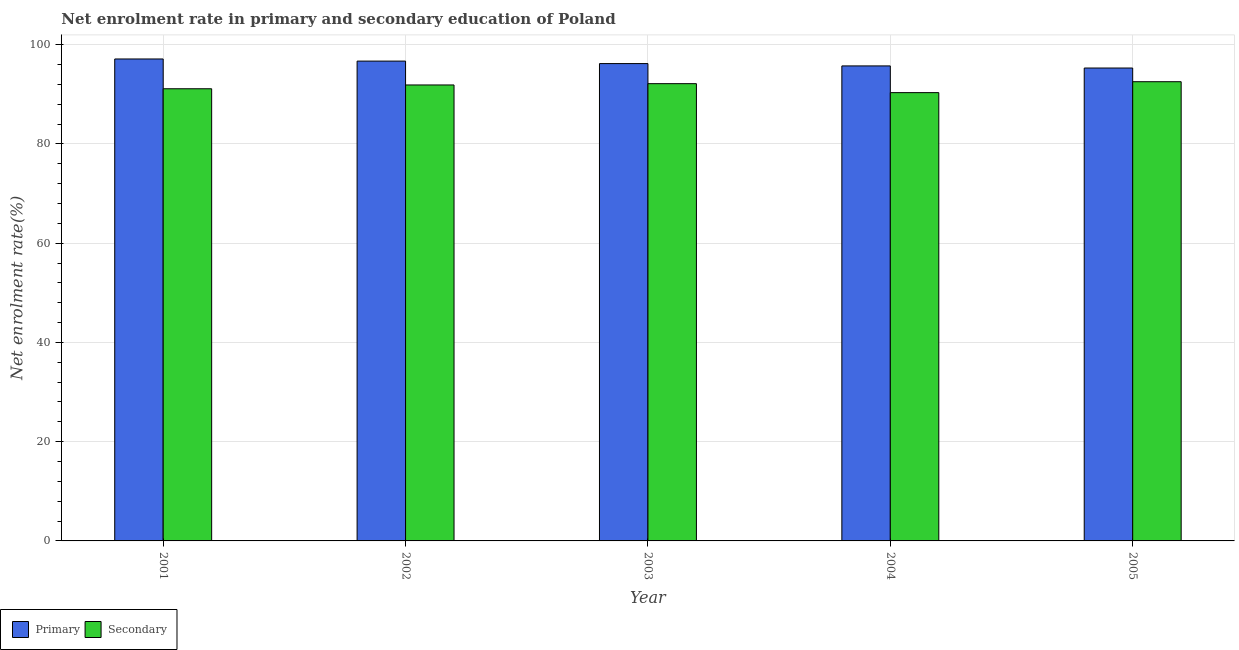How many different coloured bars are there?
Give a very brief answer. 2. How many groups of bars are there?
Offer a terse response. 5. Are the number of bars per tick equal to the number of legend labels?
Your response must be concise. Yes. Are the number of bars on each tick of the X-axis equal?
Your answer should be very brief. Yes. In how many cases, is the number of bars for a given year not equal to the number of legend labels?
Your answer should be very brief. 0. What is the enrollment rate in secondary education in 2002?
Offer a very short reply. 91.88. Across all years, what is the maximum enrollment rate in secondary education?
Your answer should be compact. 92.53. Across all years, what is the minimum enrollment rate in secondary education?
Your response must be concise. 90.33. In which year was the enrollment rate in primary education maximum?
Offer a terse response. 2001. What is the total enrollment rate in primary education in the graph?
Provide a short and direct response. 480.98. What is the difference between the enrollment rate in secondary education in 2002 and that in 2005?
Keep it short and to the point. -0.66. What is the difference between the enrollment rate in secondary education in 2005 and the enrollment rate in primary education in 2004?
Ensure brevity in your answer.  2.2. What is the average enrollment rate in primary education per year?
Ensure brevity in your answer.  96.2. In the year 2004, what is the difference between the enrollment rate in primary education and enrollment rate in secondary education?
Give a very brief answer. 0. In how many years, is the enrollment rate in primary education greater than 88 %?
Offer a very short reply. 5. What is the ratio of the enrollment rate in primary education in 2002 to that in 2003?
Your answer should be compact. 1.01. Is the difference between the enrollment rate in secondary education in 2002 and 2004 greater than the difference between the enrollment rate in primary education in 2002 and 2004?
Give a very brief answer. No. What is the difference between the highest and the second highest enrollment rate in primary education?
Provide a succinct answer. 0.43. What is the difference between the highest and the lowest enrollment rate in secondary education?
Keep it short and to the point. 2.2. What does the 2nd bar from the left in 2003 represents?
Keep it short and to the point. Secondary. What does the 2nd bar from the right in 2005 represents?
Give a very brief answer. Primary. Are all the bars in the graph horizontal?
Keep it short and to the point. No. How many years are there in the graph?
Offer a very short reply. 5. Are the values on the major ticks of Y-axis written in scientific E-notation?
Your answer should be compact. No. Where does the legend appear in the graph?
Provide a succinct answer. Bottom left. How many legend labels are there?
Your response must be concise. 2. What is the title of the graph?
Your answer should be very brief. Net enrolment rate in primary and secondary education of Poland. Does "Merchandise exports" appear as one of the legend labels in the graph?
Offer a very short reply. No. What is the label or title of the X-axis?
Make the answer very short. Year. What is the label or title of the Y-axis?
Offer a very short reply. Net enrolment rate(%). What is the Net enrolment rate(%) of Primary in 2001?
Provide a succinct answer. 97.11. What is the Net enrolment rate(%) of Secondary in 2001?
Your response must be concise. 91.11. What is the Net enrolment rate(%) of Primary in 2002?
Give a very brief answer. 96.68. What is the Net enrolment rate(%) of Secondary in 2002?
Provide a short and direct response. 91.88. What is the Net enrolment rate(%) in Primary in 2003?
Your answer should be very brief. 96.18. What is the Net enrolment rate(%) of Secondary in 2003?
Your response must be concise. 92.14. What is the Net enrolment rate(%) of Primary in 2004?
Ensure brevity in your answer.  95.71. What is the Net enrolment rate(%) in Secondary in 2004?
Make the answer very short. 90.33. What is the Net enrolment rate(%) in Primary in 2005?
Provide a short and direct response. 95.29. What is the Net enrolment rate(%) in Secondary in 2005?
Ensure brevity in your answer.  92.53. Across all years, what is the maximum Net enrolment rate(%) of Primary?
Offer a terse response. 97.11. Across all years, what is the maximum Net enrolment rate(%) in Secondary?
Offer a terse response. 92.53. Across all years, what is the minimum Net enrolment rate(%) of Primary?
Ensure brevity in your answer.  95.29. Across all years, what is the minimum Net enrolment rate(%) of Secondary?
Offer a terse response. 90.33. What is the total Net enrolment rate(%) in Primary in the graph?
Provide a succinct answer. 480.98. What is the total Net enrolment rate(%) of Secondary in the graph?
Offer a terse response. 457.99. What is the difference between the Net enrolment rate(%) of Primary in 2001 and that in 2002?
Your response must be concise. 0.43. What is the difference between the Net enrolment rate(%) of Secondary in 2001 and that in 2002?
Offer a terse response. -0.77. What is the difference between the Net enrolment rate(%) of Primary in 2001 and that in 2003?
Ensure brevity in your answer.  0.93. What is the difference between the Net enrolment rate(%) in Secondary in 2001 and that in 2003?
Make the answer very short. -1.03. What is the difference between the Net enrolment rate(%) of Primary in 2001 and that in 2004?
Make the answer very short. 1.4. What is the difference between the Net enrolment rate(%) of Secondary in 2001 and that in 2004?
Provide a short and direct response. 0.78. What is the difference between the Net enrolment rate(%) in Primary in 2001 and that in 2005?
Keep it short and to the point. 1.82. What is the difference between the Net enrolment rate(%) of Secondary in 2001 and that in 2005?
Offer a very short reply. -1.42. What is the difference between the Net enrolment rate(%) in Primary in 2002 and that in 2003?
Offer a terse response. 0.5. What is the difference between the Net enrolment rate(%) of Secondary in 2002 and that in 2003?
Make the answer very short. -0.26. What is the difference between the Net enrolment rate(%) in Primary in 2002 and that in 2004?
Offer a very short reply. 0.97. What is the difference between the Net enrolment rate(%) in Secondary in 2002 and that in 2004?
Your answer should be compact. 1.54. What is the difference between the Net enrolment rate(%) in Primary in 2002 and that in 2005?
Keep it short and to the point. 1.39. What is the difference between the Net enrolment rate(%) in Secondary in 2002 and that in 2005?
Provide a short and direct response. -0.66. What is the difference between the Net enrolment rate(%) of Primary in 2003 and that in 2004?
Ensure brevity in your answer.  0.47. What is the difference between the Net enrolment rate(%) of Secondary in 2003 and that in 2004?
Offer a very short reply. 1.81. What is the difference between the Net enrolment rate(%) in Primary in 2003 and that in 2005?
Keep it short and to the point. 0.89. What is the difference between the Net enrolment rate(%) of Secondary in 2003 and that in 2005?
Keep it short and to the point. -0.39. What is the difference between the Net enrolment rate(%) in Primary in 2004 and that in 2005?
Make the answer very short. 0.42. What is the difference between the Net enrolment rate(%) of Secondary in 2004 and that in 2005?
Give a very brief answer. -2.2. What is the difference between the Net enrolment rate(%) in Primary in 2001 and the Net enrolment rate(%) in Secondary in 2002?
Offer a terse response. 5.24. What is the difference between the Net enrolment rate(%) in Primary in 2001 and the Net enrolment rate(%) in Secondary in 2003?
Your answer should be compact. 4.97. What is the difference between the Net enrolment rate(%) of Primary in 2001 and the Net enrolment rate(%) of Secondary in 2004?
Make the answer very short. 6.78. What is the difference between the Net enrolment rate(%) of Primary in 2001 and the Net enrolment rate(%) of Secondary in 2005?
Offer a terse response. 4.58. What is the difference between the Net enrolment rate(%) in Primary in 2002 and the Net enrolment rate(%) in Secondary in 2003?
Provide a succinct answer. 4.55. What is the difference between the Net enrolment rate(%) of Primary in 2002 and the Net enrolment rate(%) of Secondary in 2004?
Provide a short and direct response. 6.35. What is the difference between the Net enrolment rate(%) in Primary in 2002 and the Net enrolment rate(%) in Secondary in 2005?
Keep it short and to the point. 4.15. What is the difference between the Net enrolment rate(%) of Primary in 2003 and the Net enrolment rate(%) of Secondary in 2004?
Provide a succinct answer. 5.85. What is the difference between the Net enrolment rate(%) in Primary in 2003 and the Net enrolment rate(%) in Secondary in 2005?
Ensure brevity in your answer.  3.65. What is the difference between the Net enrolment rate(%) of Primary in 2004 and the Net enrolment rate(%) of Secondary in 2005?
Offer a terse response. 3.18. What is the average Net enrolment rate(%) in Primary per year?
Make the answer very short. 96.2. What is the average Net enrolment rate(%) in Secondary per year?
Your answer should be very brief. 91.6. In the year 2001, what is the difference between the Net enrolment rate(%) in Primary and Net enrolment rate(%) in Secondary?
Your response must be concise. 6. In the year 2002, what is the difference between the Net enrolment rate(%) in Primary and Net enrolment rate(%) in Secondary?
Provide a succinct answer. 4.81. In the year 2003, what is the difference between the Net enrolment rate(%) of Primary and Net enrolment rate(%) of Secondary?
Your answer should be compact. 4.05. In the year 2004, what is the difference between the Net enrolment rate(%) of Primary and Net enrolment rate(%) of Secondary?
Make the answer very short. 5.38. In the year 2005, what is the difference between the Net enrolment rate(%) in Primary and Net enrolment rate(%) in Secondary?
Your response must be concise. 2.76. What is the ratio of the Net enrolment rate(%) of Primary in 2001 to that in 2003?
Provide a succinct answer. 1.01. What is the ratio of the Net enrolment rate(%) in Primary in 2001 to that in 2004?
Provide a succinct answer. 1.01. What is the ratio of the Net enrolment rate(%) of Secondary in 2001 to that in 2004?
Provide a succinct answer. 1.01. What is the ratio of the Net enrolment rate(%) of Primary in 2001 to that in 2005?
Your response must be concise. 1.02. What is the ratio of the Net enrolment rate(%) of Secondary in 2001 to that in 2005?
Your answer should be very brief. 0.98. What is the ratio of the Net enrolment rate(%) in Secondary in 2002 to that in 2003?
Provide a short and direct response. 1. What is the ratio of the Net enrolment rate(%) in Primary in 2002 to that in 2004?
Your response must be concise. 1.01. What is the ratio of the Net enrolment rate(%) of Secondary in 2002 to that in 2004?
Keep it short and to the point. 1.02. What is the ratio of the Net enrolment rate(%) of Primary in 2002 to that in 2005?
Provide a short and direct response. 1.01. What is the ratio of the Net enrolment rate(%) of Secondary in 2002 to that in 2005?
Make the answer very short. 0.99. What is the ratio of the Net enrolment rate(%) of Secondary in 2003 to that in 2004?
Make the answer very short. 1.02. What is the ratio of the Net enrolment rate(%) in Primary in 2003 to that in 2005?
Your response must be concise. 1.01. What is the ratio of the Net enrolment rate(%) of Secondary in 2004 to that in 2005?
Give a very brief answer. 0.98. What is the difference between the highest and the second highest Net enrolment rate(%) in Primary?
Give a very brief answer. 0.43. What is the difference between the highest and the second highest Net enrolment rate(%) in Secondary?
Ensure brevity in your answer.  0.39. What is the difference between the highest and the lowest Net enrolment rate(%) of Primary?
Keep it short and to the point. 1.82. What is the difference between the highest and the lowest Net enrolment rate(%) of Secondary?
Offer a terse response. 2.2. 